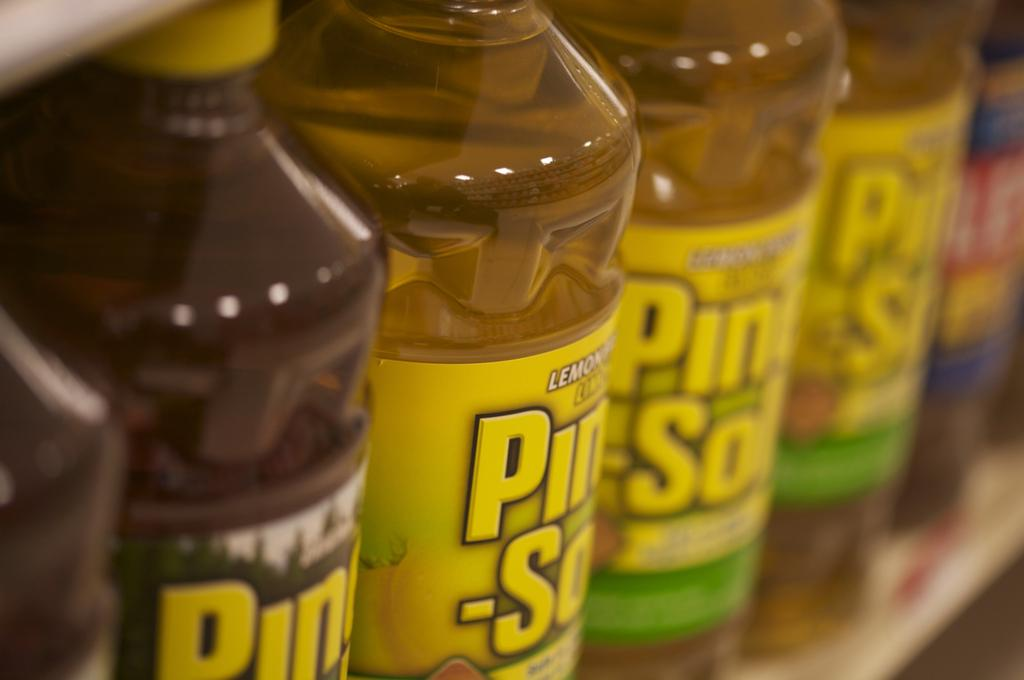<image>
Describe the image concisely. Bottles of Pine-Sol Lemon scent on a shelf. 